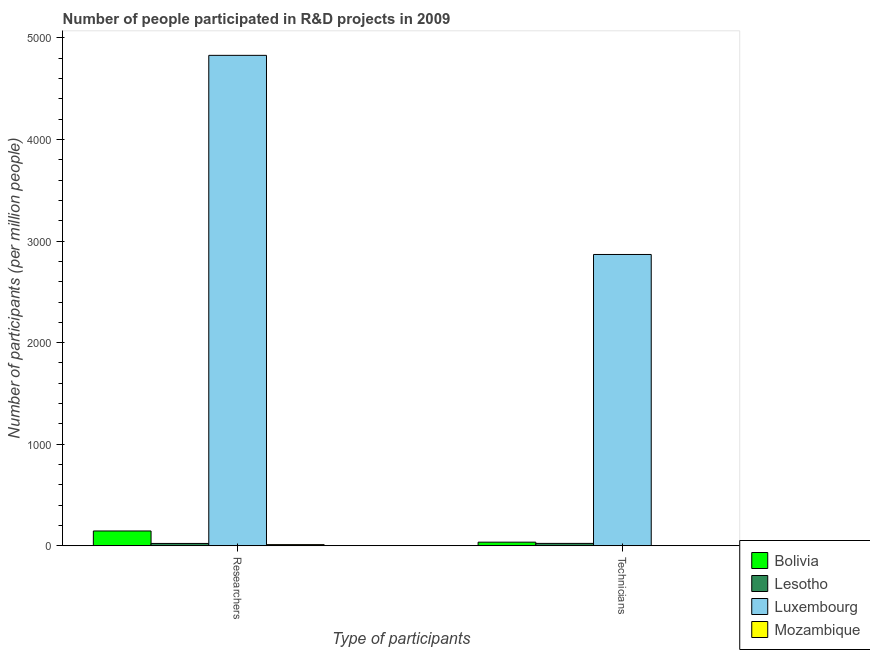How many groups of bars are there?
Keep it short and to the point. 2. Are the number of bars on each tick of the X-axis equal?
Provide a short and direct response. Yes. How many bars are there on the 1st tick from the left?
Ensure brevity in your answer.  4. How many bars are there on the 1st tick from the right?
Your answer should be compact. 4. What is the label of the 2nd group of bars from the left?
Provide a succinct answer. Technicians. What is the number of researchers in Mozambique?
Provide a short and direct response. 11.53. Across all countries, what is the maximum number of technicians?
Your answer should be compact. 2868.27. Across all countries, what is the minimum number of technicians?
Your answer should be compact. 2.01. In which country was the number of technicians maximum?
Keep it short and to the point. Luxembourg. In which country was the number of researchers minimum?
Your answer should be compact. Mozambique. What is the total number of researchers in the graph?
Make the answer very short. 5009.2. What is the difference between the number of researchers in Lesotho and that in Bolivia?
Provide a short and direct response. -122.7. What is the difference between the number of researchers in Bolivia and the number of technicians in Lesotho?
Offer a very short reply. 122.2. What is the average number of researchers per country?
Your answer should be compact. 1252.3. What is the difference between the number of technicians and number of researchers in Mozambique?
Provide a short and direct response. -9.52. In how many countries, is the number of technicians greater than 3000 ?
Give a very brief answer. 0. What is the ratio of the number of technicians in Luxembourg to that in Lesotho?
Provide a short and direct response. 121.99. Is the number of technicians in Lesotho less than that in Bolivia?
Your response must be concise. Yes. In how many countries, is the number of researchers greater than the average number of researchers taken over all countries?
Make the answer very short. 1. What does the 1st bar from the right in Technicians represents?
Ensure brevity in your answer.  Mozambique. How many bars are there?
Your answer should be compact. 8. Are all the bars in the graph horizontal?
Offer a terse response. No. What is the difference between two consecutive major ticks on the Y-axis?
Make the answer very short. 1000. Are the values on the major ticks of Y-axis written in scientific E-notation?
Provide a succinct answer. No. Does the graph contain grids?
Your answer should be very brief. No. How many legend labels are there?
Make the answer very short. 4. What is the title of the graph?
Your answer should be very brief. Number of people participated in R&D projects in 2009. What is the label or title of the X-axis?
Provide a short and direct response. Type of participants. What is the label or title of the Y-axis?
Make the answer very short. Number of participants (per million people). What is the Number of participants (per million people) in Bolivia in Researchers?
Your answer should be very brief. 145.71. What is the Number of participants (per million people) of Lesotho in Researchers?
Give a very brief answer. 23.01. What is the Number of participants (per million people) in Luxembourg in Researchers?
Your response must be concise. 4828.95. What is the Number of participants (per million people) of Mozambique in Researchers?
Offer a very short reply. 11.53. What is the Number of participants (per million people) in Bolivia in Technicians?
Keep it short and to the point. 35.56. What is the Number of participants (per million people) of Lesotho in Technicians?
Make the answer very short. 23.51. What is the Number of participants (per million people) of Luxembourg in Technicians?
Give a very brief answer. 2868.27. What is the Number of participants (per million people) in Mozambique in Technicians?
Offer a terse response. 2.01. Across all Type of participants, what is the maximum Number of participants (per million people) in Bolivia?
Your answer should be compact. 145.71. Across all Type of participants, what is the maximum Number of participants (per million people) in Lesotho?
Ensure brevity in your answer.  23.51. Across all Type of participants, what is the maximum Number of participants (per million people) of Luxembourg?
Make the answer very short. 4828.95. Across all Type of participants, what is the maximum Number of participants (per million people) of Mozambique?
Your answer should be compact. 11.53. Across all Type of participants, what is the minimum Number of participants (per million people) of Bolivia?
Keep it short and to the point. 35.56. Across all Type of participants, what is the minimum Number of participants (per million people) in Lesotho?
Make the answer very short. 23.01. Across all Type of participants, what is the minimum Number of participants (per million people) of Luxembourg?
Ensure brevity in your answer.  2868.27. Across all Type of participants, what is the minimum Number of participants (per million people) in Mozambique?
Your response must be concise. 2.01. What is the total Number of participants (per million people) in Bolivia in the graph?
Ensure brevity in your answer.  181.27. What is the total Number of participants (per million people) of Lesotho in the graph?
Offer a very short reply. 46.52. What is the total Number of participants (per million people) of Luxembourg in the graph?
Provide a succinct answer. 7697.22. What is the total Number of participants (per million people) in Mozambique in the graph?
Provide a succinct answer. 13.53. What is the difference between the Number of participants (per million people) of Bolivia in Researchers and that in Technicians?
Your answer should be very brief. 110.16. What is the difference between the Number of participants (per million people) in Lesotho in Researchers and that in Technicians?
Give a very brief answer. -0.5. What is the difference between the Number of participants (per million people) of Luxembourg in Researchers and that in Technicians?
Offer a terse response. 1960.68. What is the difference between the Number of participants (per million people) in Mozambique in Researchers and that in Technicians?
Give a very brief answer. 9.52. What is the difference between the Number of participants (per million people) in Bolivia in Researchers and the Number of participants (per million people) in Lesotho in Technicians?
Offer a terse response. 122.2. What is the difference between the Number of participants (per million people) of Bolivia in Researchers and the Number of participants (per million people) of Luxembourg in Technicians?
Ensure brevity in your answer.  -2722.56. What is the difference between the Number of participants (per million people) in Bolivia in Researchers and the Number of participants (per million people) in Mozambique in Technicians?
Give a very brief answer. 143.71. What is the difference between the Number of participants (per million people) of Lesotho in Researchers and the Number of participants (per million people) of Luxembourg in Technicians?
Ensure brevity in your answer.  -2845.26. What is the difference between the Number of participants (per million people) in Lesotho in Researchers and the Number of participants (per million people) in Mozambique in Technicians?
Provide a short and direct response. 21. What is the difference between the Number of participants (per million people) of Luxembourg in Researchers and the Number of participants (per million people) of Mozambique in Technicians?
Keep it short and to the point. 4826.94. What is the average Number of participants (per million people) of Bolivia per Type of participants?
Ensure brevity in your answer.  90.64. What is the average Number of participants (per million people) of Lesotho per Type of participants?
Give a very brief answer. 23.26. What is the average Number of participants (per million people) in Luxembourg per Type of participants?
Your answer should be very brief. 3848.61. What is the average Number of participants (per million people) of Mozambique per Type of participants?
Offer a very short reply. 6.77. What is the difference between the Number of participants (per million people) of Bolivia and Number of participants (per million people) of Lesotho in Researchers?
Provide a short and direct response. 122.7. What is the difference between the Number of participants (per million people) of Bolivia and Number of participants (per million people) of Luxembourg in Researchers?
Your response must be concise. -4683.23. What is the difference between the Number of participants (per million people) of Bolivia and Number of participants (per million people) of Mozambique in Researchers?
Keep it short and to the point. 134.19. What is the difference between the Number of participants (per million people) in Lesotho and Number of participants (per million people) in Luxembourg in Researchers?
Your response must be concise. -4805.94. What is the difference between the Number of participants (per million people) in Lesotho and Number of participants (per million people) in Mozambique in Researchers?
Ensure brevity in your answer.  11.48. What is the difference between the Number of participants (per million people) of Luxembourg and Number of participants (per million people) of Mozambique in Researchers?
Provide a succinct answer. 4817.42. What is the difference between the Number of participants (per million people) of Bolivia and Number of participants (per million people) of Lesotho in Technicians?
Your answer should be compact. 12.04. What is the difference between the Number of participants (per million people) in Bolivia and Number of participants (per million people) in Luxembourg in Technicians?
Ensure brevity in your answer.  -2832.71. What is the difference between the Number of participants (per million people) of Bolivia and Number of participants (per million people) of Mozambique in Technicians?
Keep it short and to the point. 33.55. What is the difference between the Number of participants (per million people) of Lesotho and Number of participants (per million people) of Luxembourg in Technicians?
Provide a short and direct response. -2844.76. What is the difference between the Number of participants (per million people) of Lesotho and Number of participants (per million people) of Mozambique in Technicians?
Offer a very short reply. 21.51. What is the difference between the Number of participants (per million people) in Luxembourg and Number of participants (per million people) in Mozambique in Technicians?
Provide a succinct answer. 2866.27. What is the ratio of the Number of participants (per million people) of Bolivia in Researchers to that in Technicians?
Your response must be concise. 4.1. What is the ratio of the Number of participants (per million people) in Lesotho in Researchers to that in Technicians?
Give a very brief answer. 0.98. What is the ratio of the Number of participants (per million people) of Luxembourg in Researchers to that in Technicians?
Your response must be concise. 1.68. What is the ratio of the Number of participants (per million people) in Mozambique in Researchers to that in Technicians?
Provide a succinct answer. 5.75. What is the difference between the highest and the second highest Number of participants (per million people) of Bolivia?
Keep it short and to the point. 110.16. What is the difference between the highest and the second highest Number of participants (per million people) in Lesotho?
Keep it short and to the point. 0.5. What is the difference between the highest and the second highest Number of participants (per million people) in Luxembourg?
Your answer should be very brief. 1960.68. What is the difference between the highest and the second highest Number of participants (per million people) in Mozambique?
Give a very brief answer. 9.52. What is the difference between the highest and the lowest Number of participants (per million people) in Bolivia?
Your answer should be very brief. 110.16. What is the difference between the highest and the lowest Number of participants (per million people) in Lesotho?
Provide a succinct answer. 0.5. What is the difference between the highest and the lowest Number of participants (per million people) in Luxembourg?
Provide a short and direct response. 1960.68. What is the difference between the highest and the lowest Number of participants (per million people) in Mozambique?
Your answer should be compact. 9.52. 